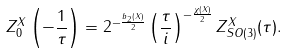<formula> <loc_0><loc_0><loc_500><loc_500>Z _ { 0 } ^ { X } \left ( - \frac { 1 } { \tau } \right ) = 2 ^ { - \frac { b _ { 2 } ( X ) } { 2 } } \left ( \frac { \tau } { i } \right ) ^ { - \frac { \chi ( X ) } { 2 } } Z _ { S O ( 3 ) } ^ { X } ( \tau ) .</formula> 